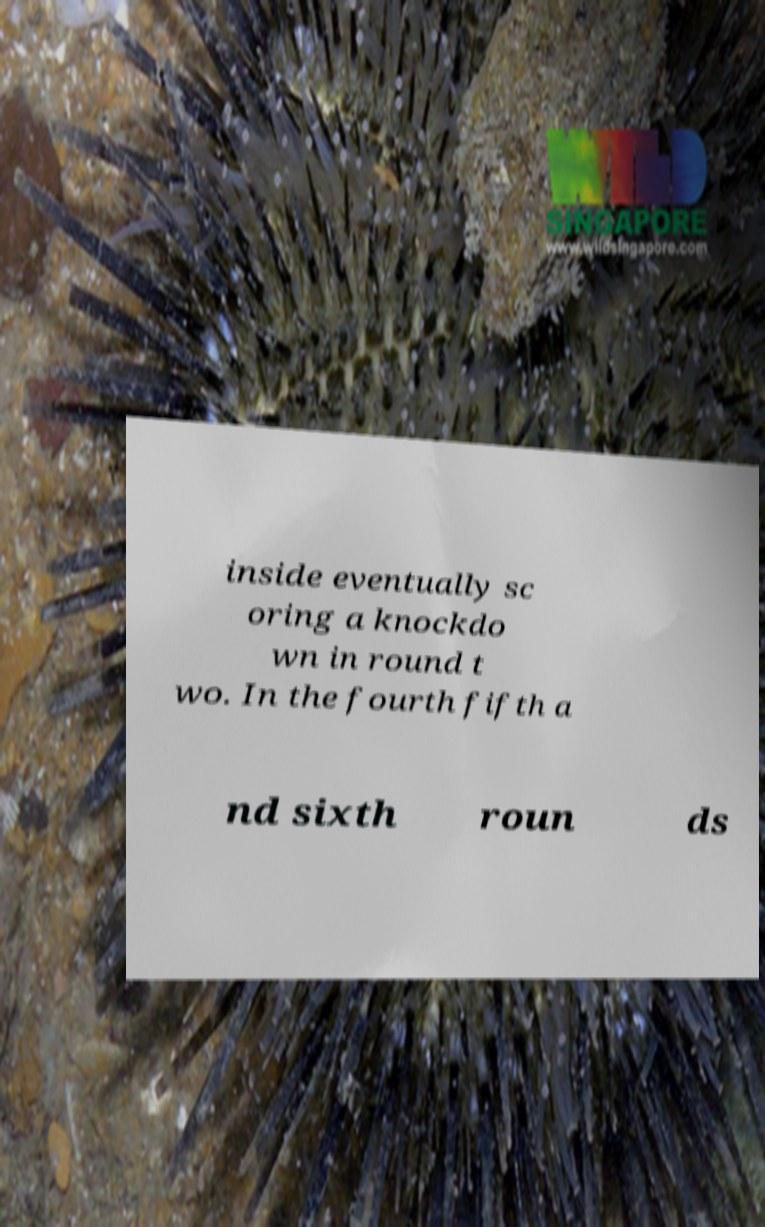For documentation purposes, I need the text within this image transcribed. Could you provide that? inside eventually sc oring a knockdo wn in round t wo. In the fourth fifth a nd sixth roun ds 